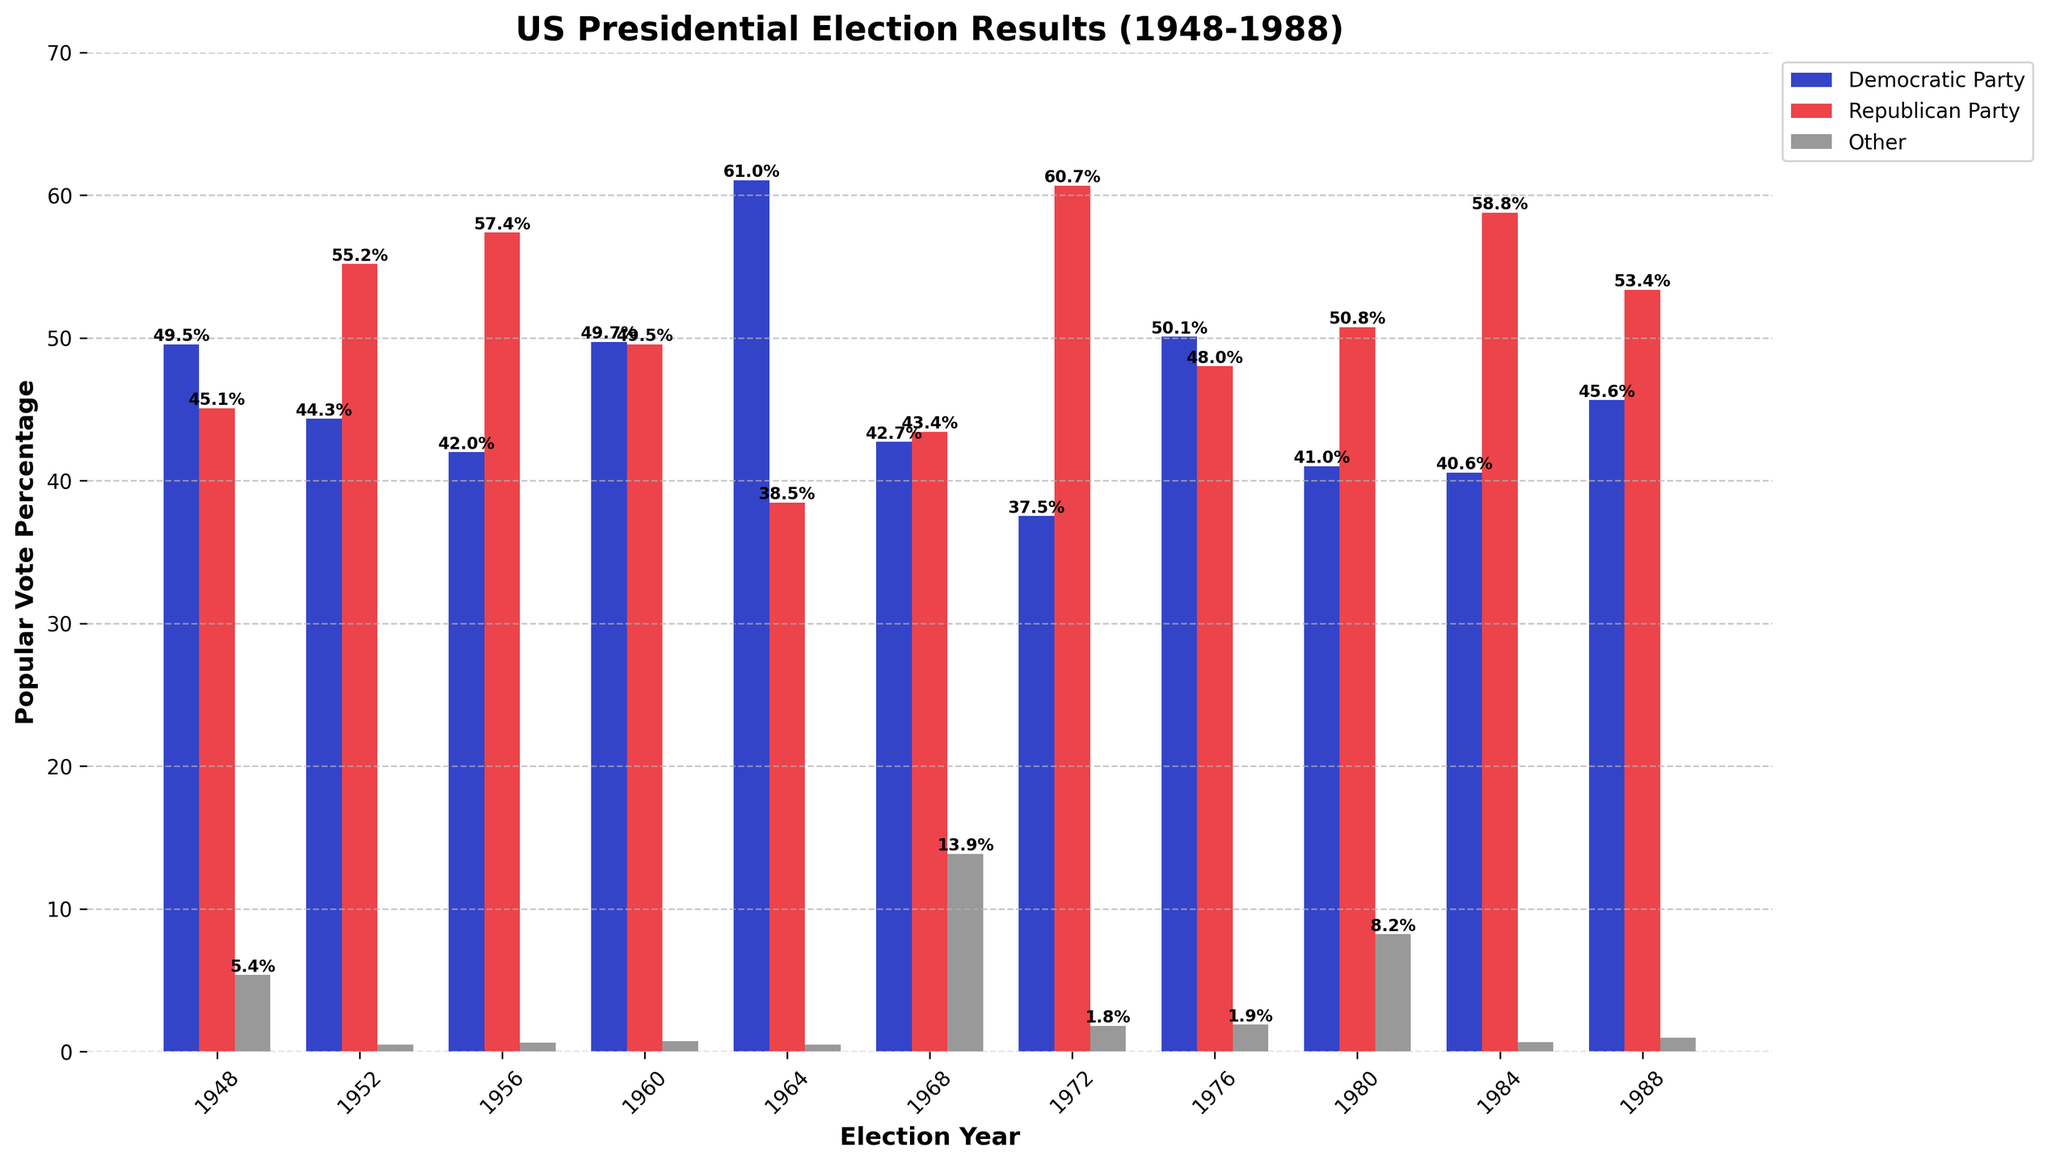What year shows the highest percentage of votes for the Democratic Party? To determine the highest percentage of votes for the Democratic Party, examine the bar heights for the Democratic Party in each year and identify the peak. The highest bar for the Democratic Party appears in 1964 with 61.05%.
Answer: 1964 Which party received more popular votes in the 1972 election? Compare the heights of the bars for the Democratic Party and the Republican Party for the year 1972. The bar for the Republican Party is higher at 60.67%, whereas the Democratic Party has 37.52%.
Answer: Republican Party How much higher is the popular vote percentage for the Republican Party in 1956 compared to 1952? Look at the bar heights for the Republican Party in 1952 and 1956. The 1956 bar reads 57.37%, and the 1952 bar reads 55.18%. Calculate the difference: 57.37% - 55.18% = 2.19%.
Answer: 2.19% In which election year did the 'Other' category receive the highest percentage of votes? Identify the year with the tallest bar in the 'Other' category. The tallest bar for the 'Other' category is in 1968 with 13.86%.
Answer: 1968 Which party won the 1984 election, and what was the percentage difference between the two major parties? Compare the bar heights for the Democratic Party and the Republican Party in 1984. The Republican Party bar is at 58.77%, and the Democratic Party is at 40.56%. Calculate the difference: 58.77% - 40.56% = 18.21%.
Answer: Republican Party, 18.21% For which year is the difference between Democratic and Republican popular votes the smallest? Calculate the difference between the Democratic and Republican bars for each year and identify the smallest difference. In 1960, the Democratic bar is at 49.72% and the Republican bar is at 49.55%. The difference is 49.72% - 49.55% = 0.17%.
Answer: 1960 How many years did the Democratic Party receive more than 50% of the popular vote? Count the number of years where the Democratic bar surpasses 50%. The Democratic Party received more than 50% in 1948, 1964, and 1976, totaling 3 years.
Answer: 3 years Which election years had a third-party vote share greater than 5%? Examine the heights of the 'Other' category bars and find the years where the value surpasses 5%. The years are 1948, 1968, and 1980 with 5.38%, 13.86%, and 8.24% respectively.
Answer: 1948, 1968, 1980 How did the vote percentages for major parties change from 1980 to 1984? Compare the bars for the Democratic and Republican Parties between 1980 and 1984. The Democratic percentage decreases from 41.01% in 1980 to 40.56% in 1984 (a decrease of 0.45%). The Republican percentage increases from 50.75% in 1980 to 58.77% in 1984 (an increase of 8.02%).
Answer: Democratic decreased by 0.45%, Republican increased by 8.02% In which election years did the Republican Party win with more than 55% of the popular vote? Look for years where the Republican bar exceeds 55%. The years are 1952, 1956, 1972, and 1984 with 55.18%, 57.37%, 60.67%, and 58.77% respectively.
Answer: 1952, 1956, 1972, 1984 